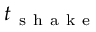<formula> <loc_0><loc_0><loc_500><loc_500>t _ { s h a k e }</formula> 